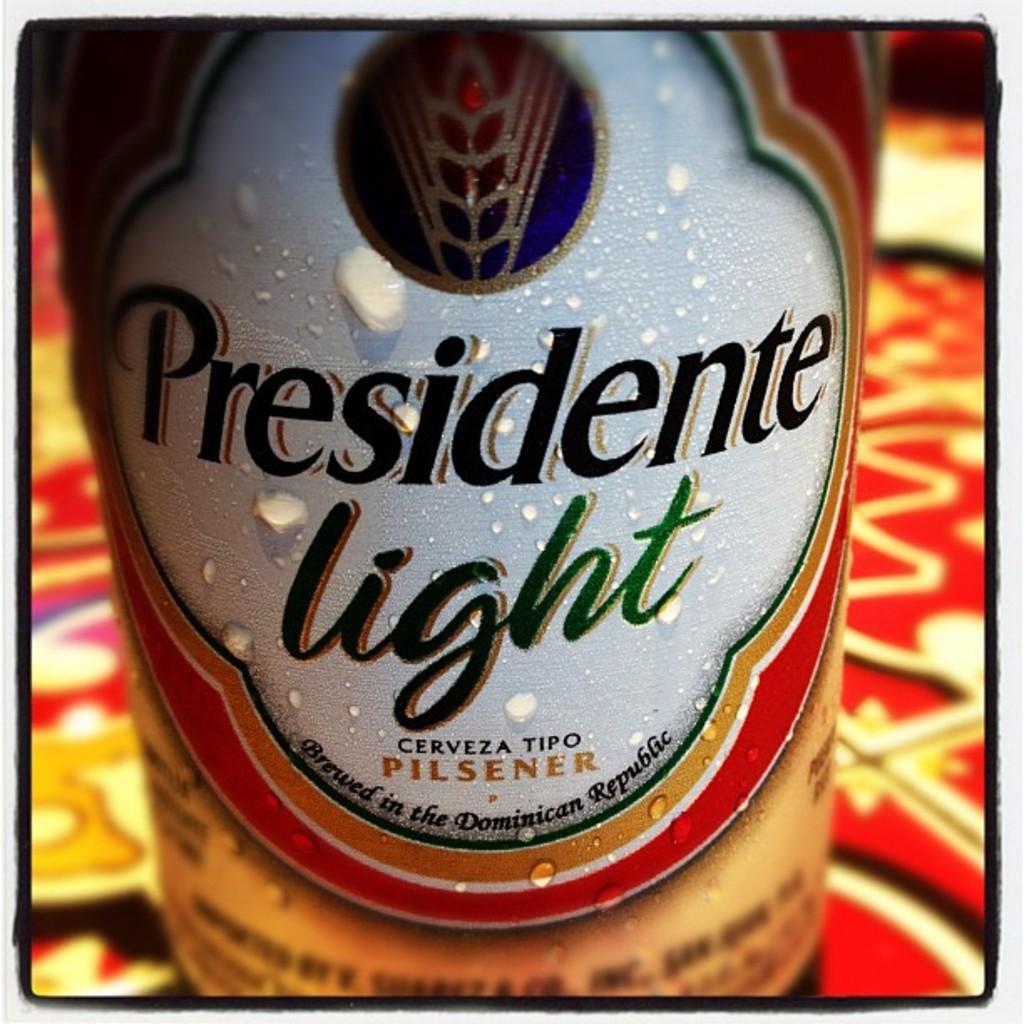What brand of beer?
Make the answer very short. Presidente light. What is the first letter of the name of the beer?
Keep it short and to the point. P. 